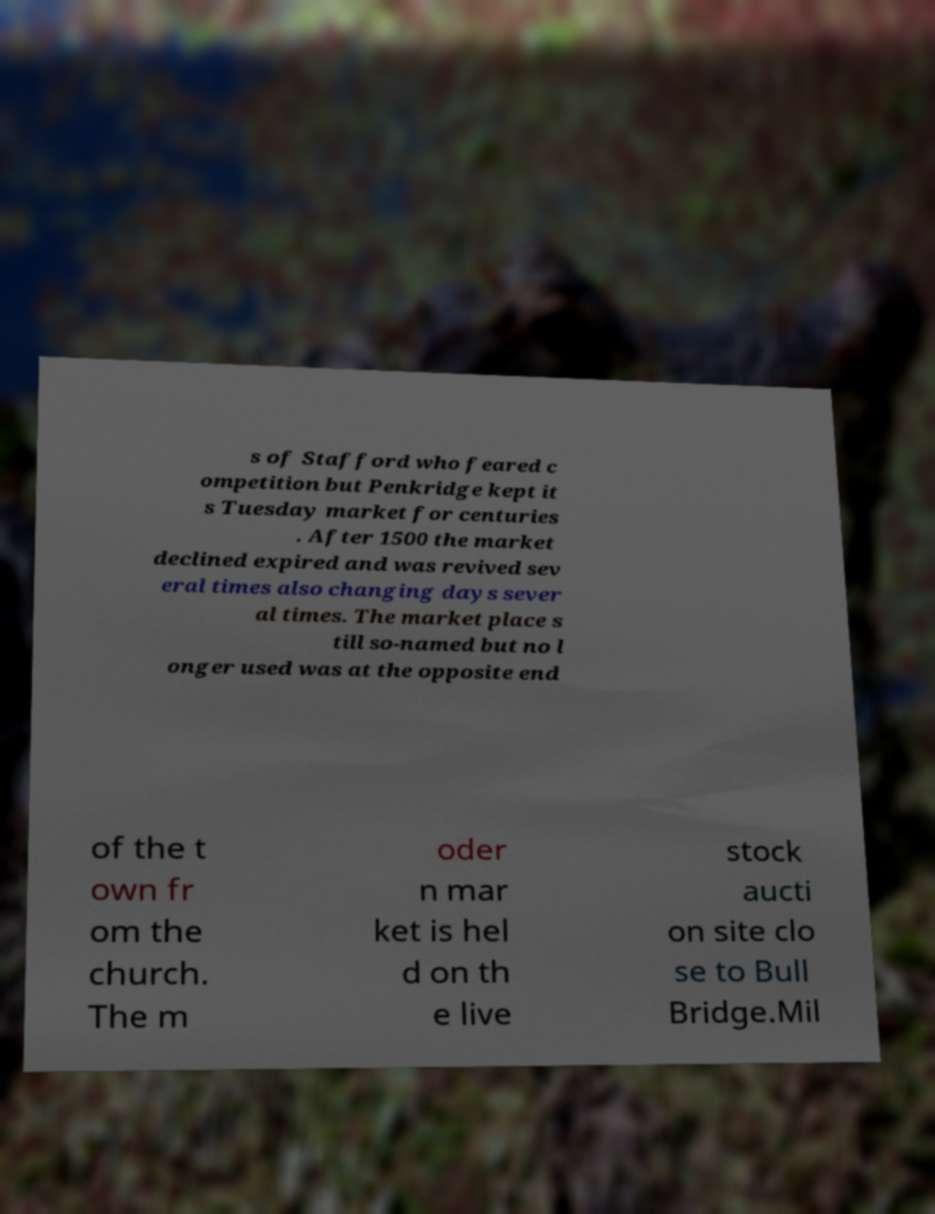I need the written content from this picture converted into text. Can you do that? s of Stafford who feared c ompetition but Penkridge kept it s Tuesday market for centuries . After 1500 the market declined expired and was revived sev eral times also changing days sever al times. The market place s till so-named but no l onger used was at the opposite end of the t own fr om the church. The m oder n mar ket is hel d on th e live stock aucti on site clo se to Bull Bridge.Mil 